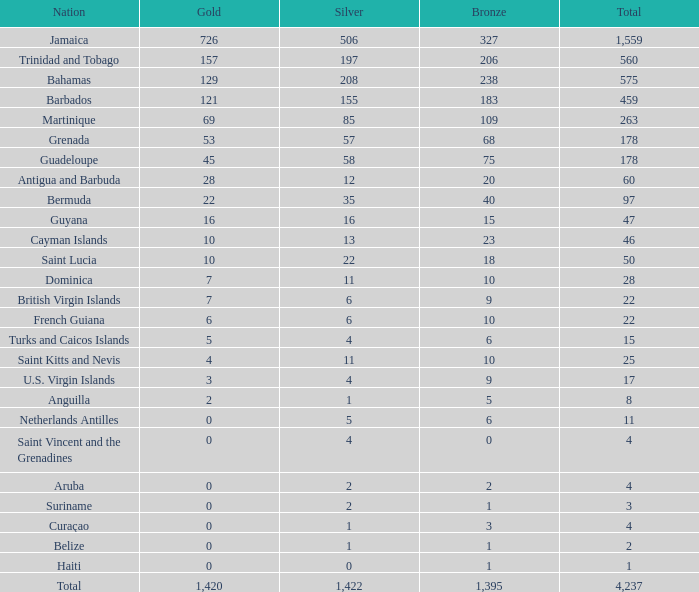What is the aggregate of gold with a bronze more than 15, silver smaller than 197, the territory of saint lucia, and with a total that is higher than 50? None. 